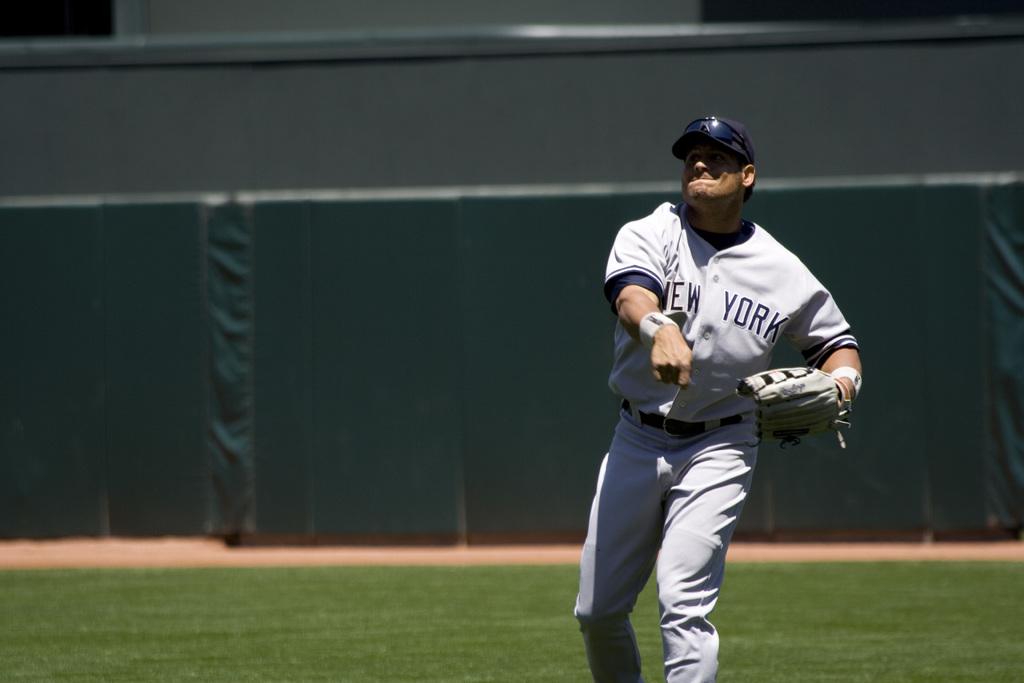What does the jersey say?
Your answer should be compact. New york. 